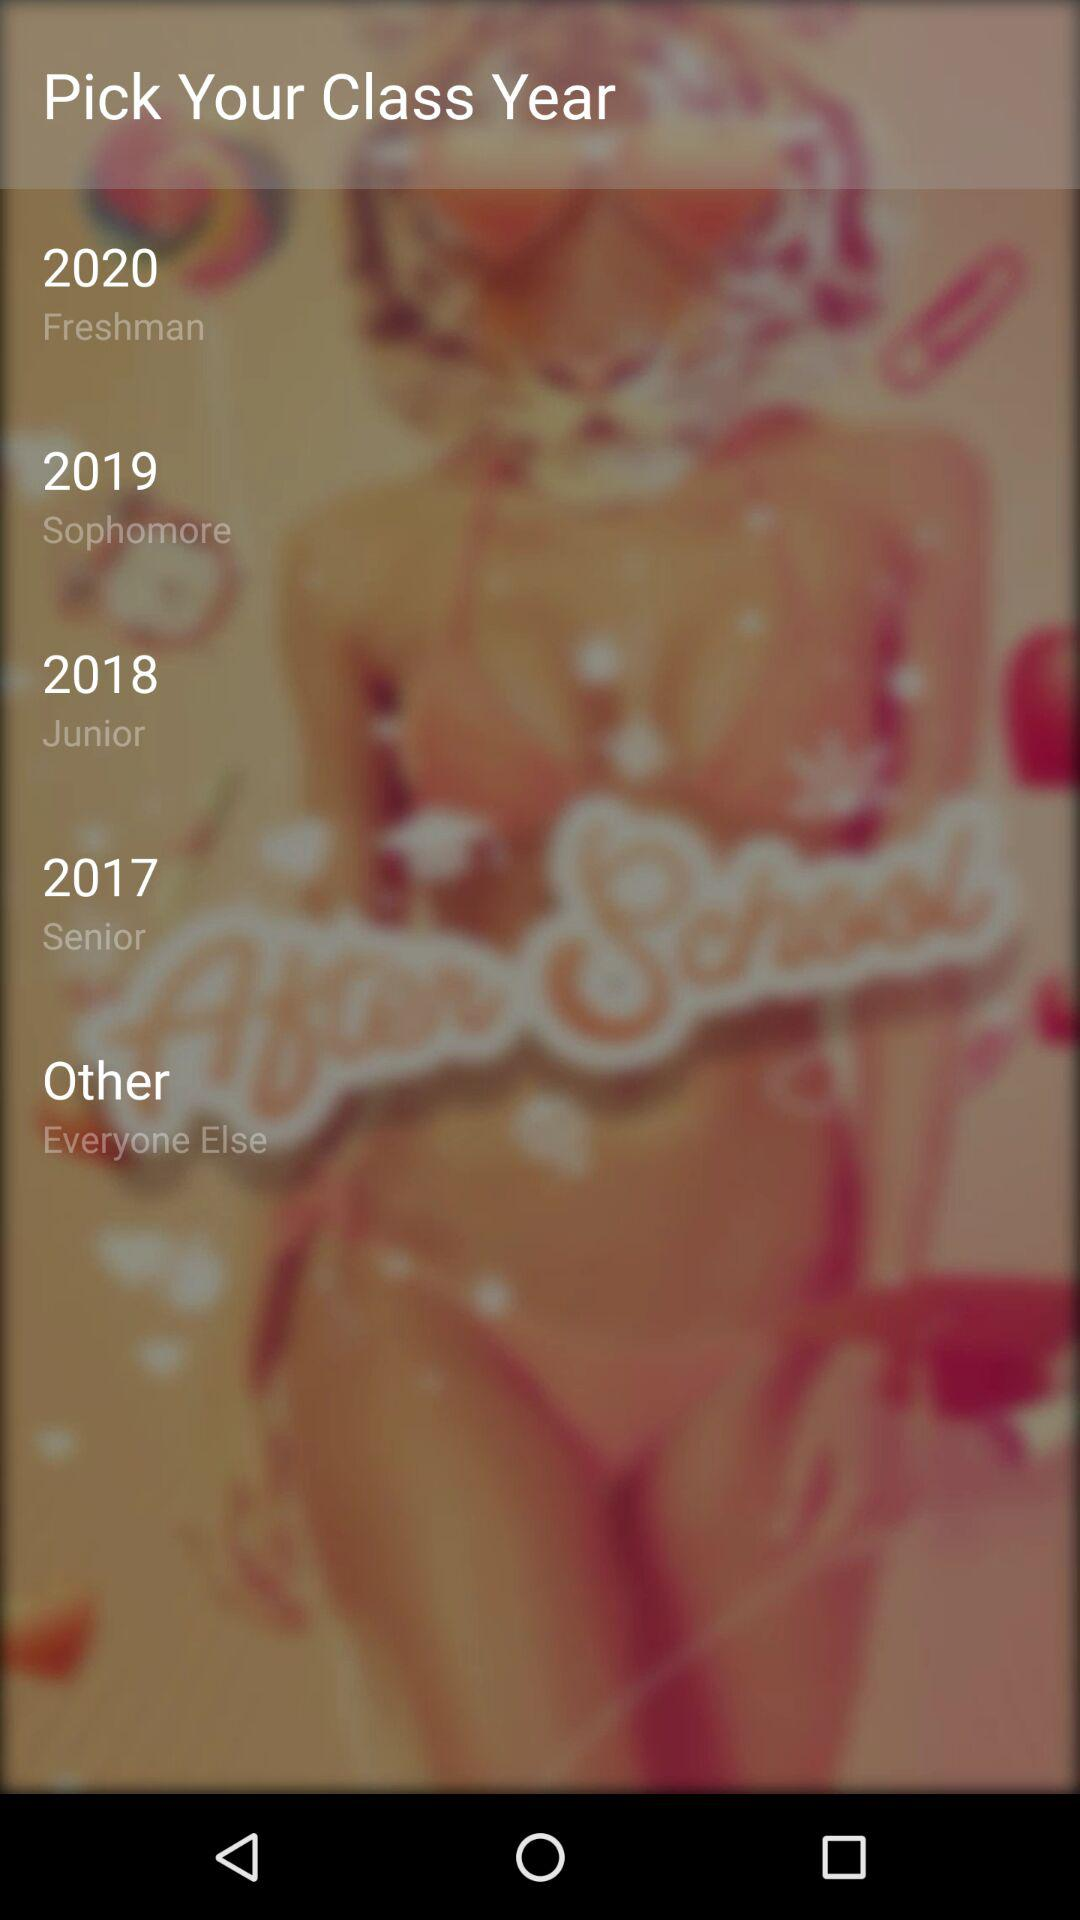Which year is for "Junior"? The year is 2018. 